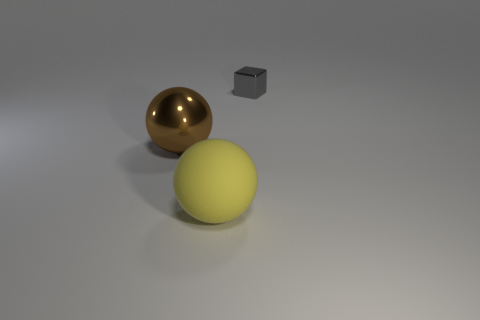Are there any other things that are the same shape as the small gray thing?
Give a very brief answer. No. There is a large shiny thing; are there any objects to the right of it?
Ensure brevity in your answer.  Yes. Are there the same number of big brown balls on the left side of the brown metallic sphere and small shiny things left of the tiny gray block?
Your response must be concise. Yes. What number of large cyan matte things are there?
Offer a terse response. 0. Are there more tiny gray things that are behind the shiny sphere than big brown rubber spheres?
Offer a very short reply. Yes. There is a large sphere that is in front of the brown thing; what is it made of?
Make the answer very short. Rubber. There is a large shiny object that is the same shape as the large matte object; what color is it?
Provide a short and direct response. Brown. How many small things are the same color as the big matte sphere?
Your answer should be very brief. 0. There is a ball behind the yellow matte ball; is it the same size as the sphere in front of the metal ball?
Offer a very short reply. Yes. There is a brown sphere; is its size the same as the thing that is to the right of the rubber ball?
Offer a terse response. No. 